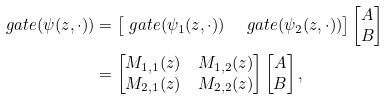Convert formula to latex. <formula><loc_0><loc_0><loc_500><loc_500>\ g a t e ( \psi ( z , \cdot ) ) & = \begin{bmatrix} \ g a t e ( \psi _ { 1 } ( z , \cdot ) ) & \ g a t e ( \psi _ { 2 } ( z , \cdot ) ) \end{bmatrix} \begin{bmatrix} A \\ B \end{bmatrix} \\ & = \begin{bmatrix} M _ { 1 , 1 } ( z ) & M _ { 1 , 2 } ( z ) \\ M _ { 2 , 1 } ( z ) & M _ { 2 , 2 } ( z ) \end{bmatrix} \begin{bmatrix} A \\ B \end{bmatrix} ,</formula> 